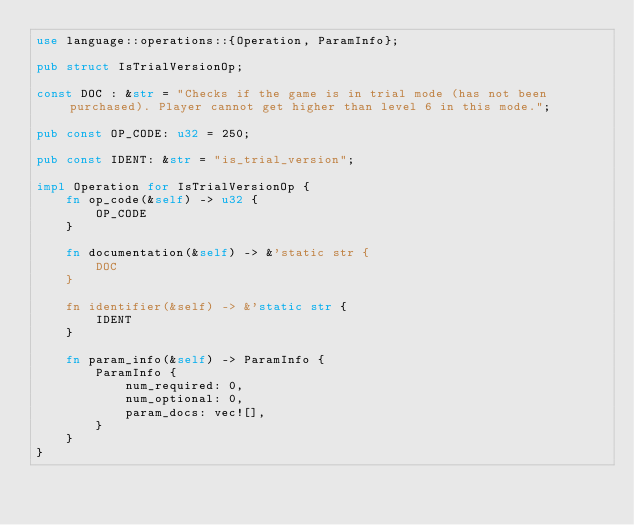<code> <loc_0><loc_0><loc_500><loc_500><_Rust_>use language::operations::{Operation, ParamInfo};

pub struct IsTrialVersionOp;

const DOC : &str = "Checks if the game is in trial mode (has not been purchased). Player cannot get higher than level 6 in this mode.";

pub const OP_CODE: u32 = 250;

pub const IDENT: &str = "is_trial_version";

impl Operation for IsTrialVersionOp {
    fn op_code(&self) -> u32 {
        OP_CODE
    }

    fn documentation(&self) -> &'static str {
        DOC
    }

    fn identifier(&self) -> &'static str {
        IDENT
    }

    fn param_info(&self) -> ParamInfo {
        ParamInfo {
            num_required: 0,
            num_optional: 0,
            param_docs: vec![],
        }
    }
}
</code> 